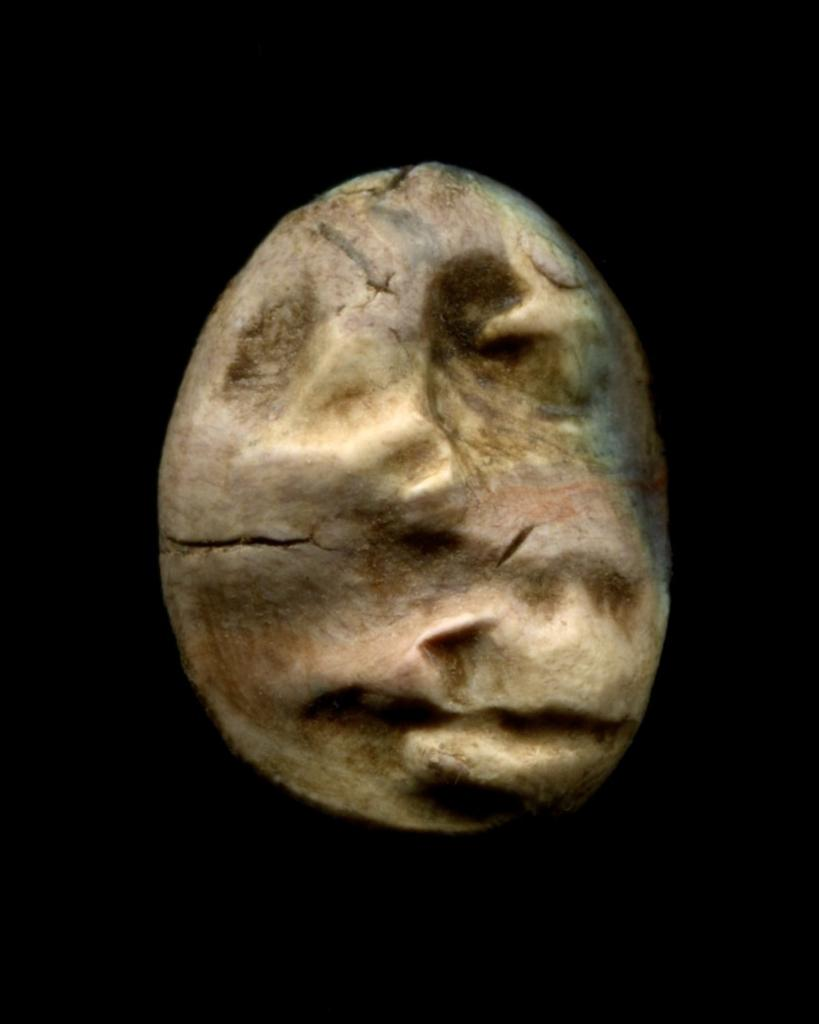What is the main subject of the image? There is an object in the image. What color is the background of the image? The background of the image is black. What is the belief of the object in the image? There is no indication of any belief associated with the object in the image. What type of lip can be seen on the object in the image? There is no lip present on the object in the image. 